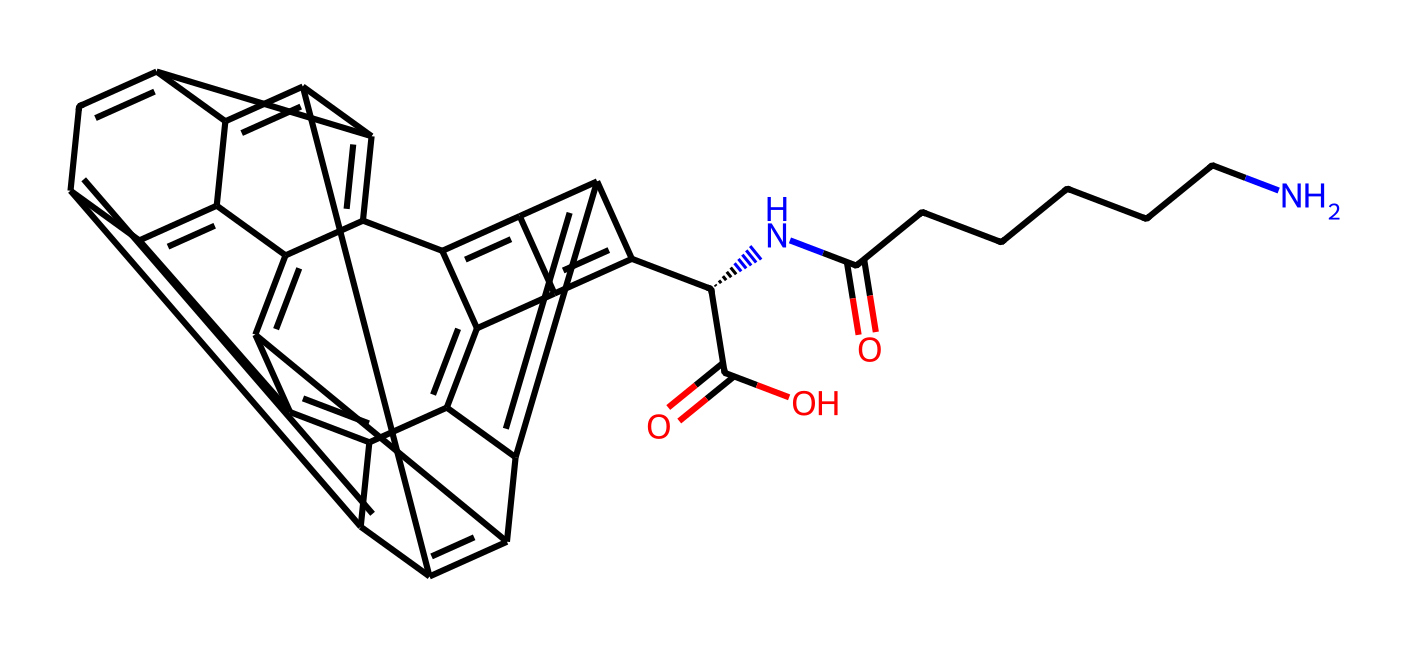how many carbon atoms are in the structure? By analyzing the SMILES representation, we can identify the number of carbon atoms. Each 'C' in the SMILES corresponds to a carbon atom, and we can count 26 occurrences of 'C'.
Answer: 26 what is the main functional group present in this chemical? The functional groups can be identified based on common structural features. The presence of 'C(=O)' suggests there are carbonyl groups, indicating that carboxylic acid groups (–COOH) are present.
Answer: carboxylic acid how many rings are present in this fullerene structure? The structure is based on the connectivity of carbon atoms. In fullerenes, the arrangement often results in a series of interconnected rings. Counting the rings visually from the SMILES, we identify that there are 12 rings.
Answer: 12 what type of isomerism is present in this chemical structure? The structure includes a chiral center at 'C[@H]', which means there is a possibility of geometric or optical isomerism due to the presence of one or more chiral centers. Therefore, we can conclude that this chemical can exhibit stereoisomerism.
Answer: stereoisomerism is this fullerene likely to be soluble in organic solvents? Fullerenes, especially functionalized ones, often maintain a hydrophobic character due to their carbon framework. The presence of functional groups can increase its solubility in organic solvents while still retaining some hydrophobic properties.
Answer: yes what is the significance of the nitrogen atom in the structure? The nitrogen atom is linked to the hydrocarbon chain (–NC(=O)CCCCCN), which suggests a potential for interaction in data storage applications. This integration impacts the properties of the fullerenes, potentially enhancing electron donation or accepting abilities.
Answer: electron donor 